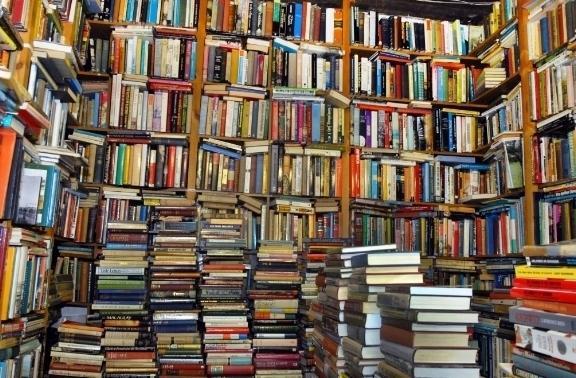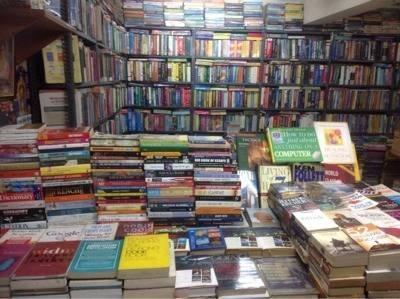The first image is the image on the left, the second image is the image on the right. Evaluate the accuracy of this statement regarding the images: "In the book store there are at least 10 stuff bears ranging in color from pink, orange and purple sit on the top back self.". Is it true? Answer yes or no. No. The first image is the image on the left, the second image is the image on the right. Examine the images to the left and right. Is the description "People are looking at the merchandise." accurate? Answer yes or no. No. 